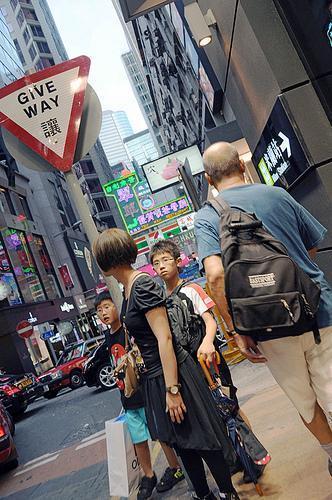How many women?
Give a very brief answer. 1. 